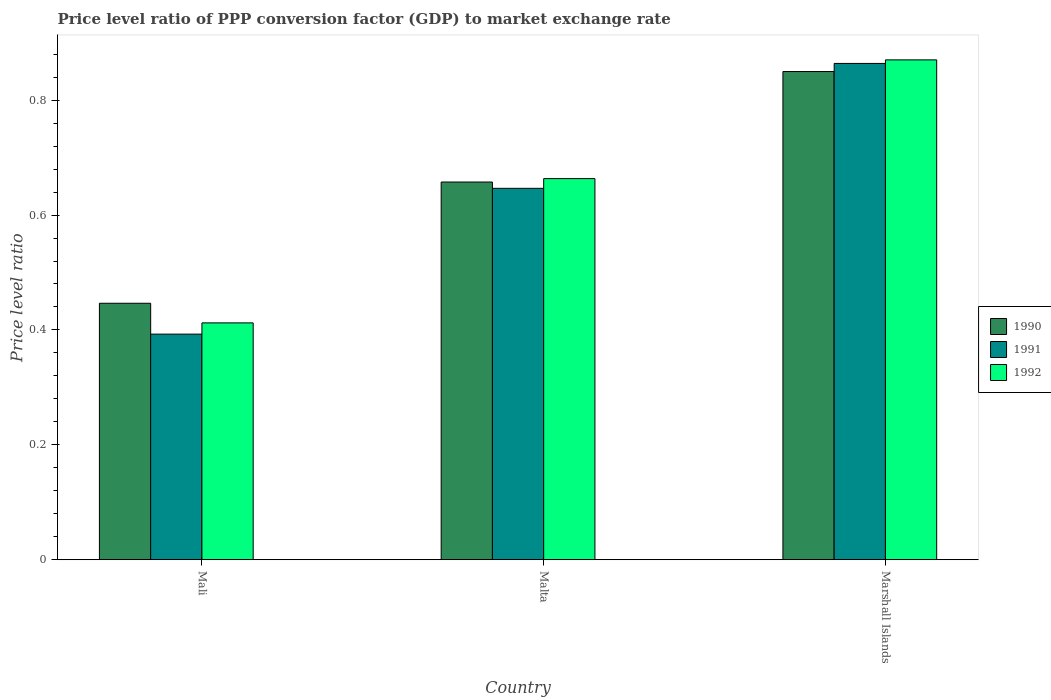How many different coloured bars are there?
Your answer should be very brief. 3. How many groups of bars are there?
Ensure brevity in your answer.  3. Are the number of bars on each tick of the X-axis equal?
Your answer should be very brief. Yes. How many bars are there on the 1st tick from the left?
Provide a short and direct response. 3. What is the label of the 1st group of bars from the left?
Provide a succinct answer. Mali. What is the price level ratio in 1992 in Marshall Islands?
Make the answer very short. 0.87. Across all countries, what is the maximum price level ratio in 1990?
Keep it short and to the point. 0.85. Across all countries, what is the minimum price level ratio in 1990?
Offer a terse response. 0.45. In which country was the price level ratio in 1990 maximum?
Your response must be concise. Marshall Islands. In which country was the price level ratio in 1991 minimum?
Your response must be concise. Mali. What is the total price level ratio in 1991 in the graph?
Provide a short and direct response. 1.9. What is the difference between the price level ratio in 1990 in Mali and that in Marshall Islands?
Provide a short and direct response. -0.4. What is the difference between the price level ratio in 1992 in Marshall Islands and the price level ratio in 1991 in Mali?
Provide a succinct answer. 0.48. What is the average price level ratio in 1990 per country?
Ensure brevity in your answer.  0.65. What is the difference between the price level ratio of/in 1992 and price level ratio of/in 1990 in Malta?
Offer a very short reply. 0.01. In how many countries, is the price level ratio in 1992 greater than 0.32?
Your answer should be very brief. 3. What is the ratio of the price level ratio in 1991 in Mali to that in Marshall Islands?
Make the answer very short. 0.45. Is the price level ratio in 1990 in Malta less than that in Marshall Islands?
Give a very brief answer. Yes. Is the difference between the price level ratio in 1992 in Mali and Marshall Islands greater than the difference between the price level ratio in 1990 in Mali and Marshall Islands?
Your response must be concise. No. What is the difference between the highest and the second highest price level ratio in 1991?
Ensure brevity in your answer.  0.22. What is the difference between the highest and the lowest price level ratio in 1992?
Your answer should be very brief. 0.46. In how many countries, is the price level ratio in 1990 greater than the average price level ratio in 1990 taken over all countries?
Your answer should be very brief. 2. What does the 2nd bar from the left in Mali represents?
Offer a terse response. 1991. What does the 3rd bar from the right in Marshall Islands represents?
Ensure brevity in your answer.  1990. How many bars are there?
Make the answer very short. 9. Are all the bars in the graph horizontal?
Make the answer very short. No. Does the graph contain grids?
Provide a short and direct response. No. Where does the legend appear in the graph?
Your answer should be very brief. Center right. What is the title of the graph?
Offer a terse response. Price level ratio of PPP conversion factor (GDP) to market exchange rate. Does "1989" appear as one of the legend labels in the graph?
Make the answer very short. No. What is the label or title of the Y-axis?
Your response must be concise. Price level ratio. What is the Price level ratio in 1990 in Mali?
Give a very brief answer. 0.45. What is the Price level ratio of 1991 in Mali?
Provide a succinct answer. 0.39. What is the Price level ratio of 1992 in Mali?
Provide a succinct answer. 0.41. What is the Price level ratio in 1990 in Malta?
Your response must be concise. 0.66. What is the Price level ratio in 1991 in Malta?
Give a very brief answer. 0.65. What is the Price level ratio of 1992 in Malta?
Provide a short and direct response. 0.66. What is the Price level ratio of 1990 in Marshall Islands?
Offer a terse response. 0.85. What is the Price level ratio of 1991 in Marshall Islands?
Offer a terse response. 0.86. What is the Price level ratio of 1992 in Marshall Islands?
Your answer should be compact. 0.87. Across all countries, what is the maximum Price level ratio in 1990?
Offer a very short reply. 0.85. Across all countries, what is the maximum Price level ratio of 1991?
Your answer should be compact. 0.86. Across all countries, what is the maximum Price level ratio of 1992?
Your answer should be very brief. 0.87. Across all countries, what is the minimum Price level ratio of 1990?
Provide a succinct answer. 0.45. Across all countries, what is the minimum Price level ratio in 1991?
Your answer should be very brief. 0.39. Across all countries, what is the minimum Price level ratio of 1992?
Offer a terse response. 0.41. What is the total Price level ratio in 1990 in the graph?
Your response must be concise. 1.95. What is the total Price level ratio in 1991 in the graph?
Ensure brevity in your answer.  1.9. What is the total Price level ratio in 1992 in the graph?
Provide a short and direct response. 1.95. What is the difference between the Price level ratio of 1990 in Mali and that in Malta?
Keep it short and to the point. -0.21. What is the difference between the Price level ratio in 1991 in Mali and that in Malta?
Your response must be concise. -0.25. What is the difference between the Price level ratio of 1992 in Mali and that in Malta?
Provide a succinct answer. -0.25. What is the difference between the Price level ratio of 1990 in Mali and that in Marshall Islands?
Offer a terse response. -0.4. What is the difference between the Price level ratio of 1991 in Mali and that in Marshall Islands?
Give a very brief answer. -0.47. What is the difference between the Price level ratio in 1992 in Mali and that in Marshall Islands?
Keep it short and to the point. -0.46. What is the difference between the Price level ratio of 1990 in Malta and that in Marshall Islands?
Your response must be concise. -0.19. What is the difference between the Price level ratio of 1991 in Malta and that in Marshall Islands?
Provide a succinct answer. -0.22. What is the difference between the Price level ratio of 1992 in Malta and that in Marshall Islands?
Your answer should be compact. -0.21. What is the difference between the Price level ratio of 1990 in Mali and the Price level ratio of 1991 in Malta?
Provide a succinct answer. -0.2. What is the difference between the Price level ratio of 1990 in Mali and the Price level ratio of 1992 in Malta?
Offer a terse response. -0.22. What is the difference between the Price level ratio of 1991 in Mali and the Price level ratio of 1992 in Malta?
Provide a short and direct response. -0.27. What is the difference between the Price level ratio in 1990 in Mali and the Price level ratio in 1991 in Marshall Islands?
Provide a short and direct response. -0.42. What is the difference between the Price level ratio of 1990 in Mali and the Price level ratio of 1992 in Marshall Islands?
Make the answer very short. -0.42. What is the difference between the Price level ratio of 1991 in Mali and the Price level ratio of 1992 in Marshall Islands?
Your answer should be compact. -0.48. What is the difference between the Price level ratio in 1990 in Malta and the Price level ratio in 1991 in Marshall Islands?
Provide a succinct answer. -0.21. What is the difference between the Price level ratio in 1990 in Malta and the Price level ratio in 1992 in Marshall Islands?
Give a very brief answer. -0.21. What is the difference between the Price level ratio in 1991 in Malta and the Price level ratio in 1992 in Marshall Islands?
Offer a terse response. -0.22. What is the average Price level ratio of 1990 per country?
Keep it short and to the point. 0.65. What is the average Price level ratio of 1991 per country?
Your answer should be very brief. 0.63. What is the average Price level ratio in 1992 per country?
Your answer should be compact. 0.65. What is the difference between the Price level ratio of 1990 and Price level ratio of 1991 in Mali?
Your answer should be compact. 0.05. What is the difference between the Price level ratio in 1990 and Price level ratio in 1992 in Mali?
Offer a terse response. 0.03. What is the difference between the Price level ratio in 1991 and Price level ratio in 1992 in Mali?
Your response must be concise. -0.02. What is the difference between the Price level ratio of 1990 and Price level ratio of 1991 in Malta?
Offer a very short reply. 0.01. What is the difference between the Price level ratio of 1990 and Price level ratio of 1992 in Malta?
Ensure brevity in your answer.  -0.01. What is the difference between the Price level ratio in 1991 and Price level ratio in 1992 in Malta?
Your response must be concise. -0.02. What is the difference between the Price level ratio in 1990 and Price level ratio in 1991 in Marshall Islands?
Provide a succinct answer. -0.01. What is the difference between the Price level ratio of 1990 and Price level ratio of 1992 in Marshall Islands?
Provide a succinct answer. -0.02. What is the difference between the Price level ratio in 1991 and Price level ratio in 1992 in Marshall Islands?
Your response must be concise. -0.01. What is the ratio of the Price level ratio of 1990 in Mali to that in Malta?
Provide a succinct answer. 0.68. What is the ratio of the Price level ratio of 1991 in Mali to that in Malta?
Provide a short and direct response. 0.61. What is the ratio of the Price level ratio of 1992 in Mali to that in Malta?
Ensure brevity in your answer.  0.62. What is the ratio of the Price level ratio in 1990 in Mali to that in Marshall Islands?
Your answer should be compact. 0.53. What is the ratio of the Price level ratio in 1991 in Mali to that in Marshall Islands?
Your answer should be very brief. 0.45. What is the ratio of the Price level ratio of 1992 in Mali to that in Marshall Islands?
Offer a very short reply. 0.47. What is the ratio of the Price level ratio of 1990 in Malta to that in Marshall Islands?
Offer a terse response. 0.77. What is the ratio of the Price level ratio of 1991 in Malta to that in Marshall Islands?
Provide a succinct answer. 0.75. What is the ratio of the Price level ratio in 1992 in Malta to that in Marshall Islands?
Ensure brevity in your answer.  0.76. What is the difference between the highest and the second highest Price level ratio of 1990?
Keep it short and to the point. 0.19. What is the difference between the highest and the second highest Price level ratio in 1991?
Provide a succinct answer. 0.22. What is the difference between the highest and the second highest Price level ratio of 1992?
Offer a terse response. 0.21. What is the difference between the highest and the lowest Price level ratio in 1990?
Your answer should be very brief. 0.4. What is the difference between the highest and the lowest Price level ratio in 1991?
Keep it short and to the point. 0.47. What is the difference between the highest and the lowest Price level ratio of 1992?
Ensure brevity in your answer.  0.46. 